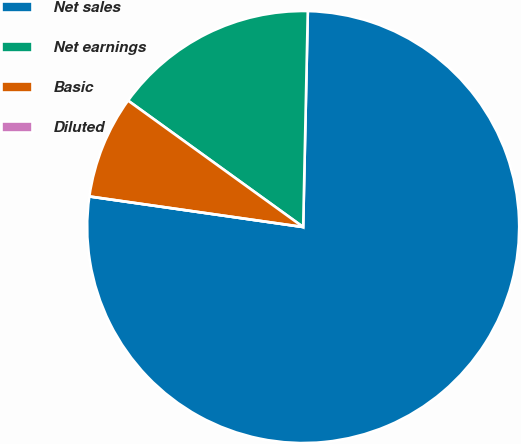Convert chart. <chart><loc_0><loc_0><loc_500><loc_500><pie_chart><fcel>Net sales<fcel>Net earnings<fcel>Basic<fcel>Diluted<nl><fcel>76.92%<fcel>15.39%<fcel>7.69%<fcel>0.0%<nl></chart> 